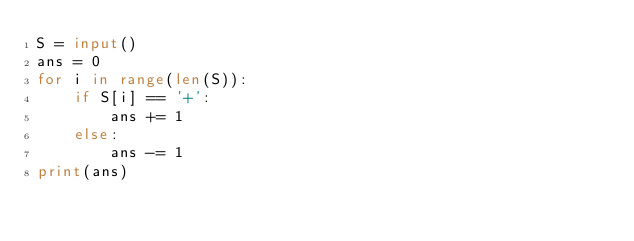Convert code to text. <code><loc_0><loc_0><loc_500><loc_500><_Python_>S = input()
ans = 0
for i in range(len(S)):
    if S[i] == '+':
        ans += 1
    else:
        ans -= 1
print(ans)</code> 